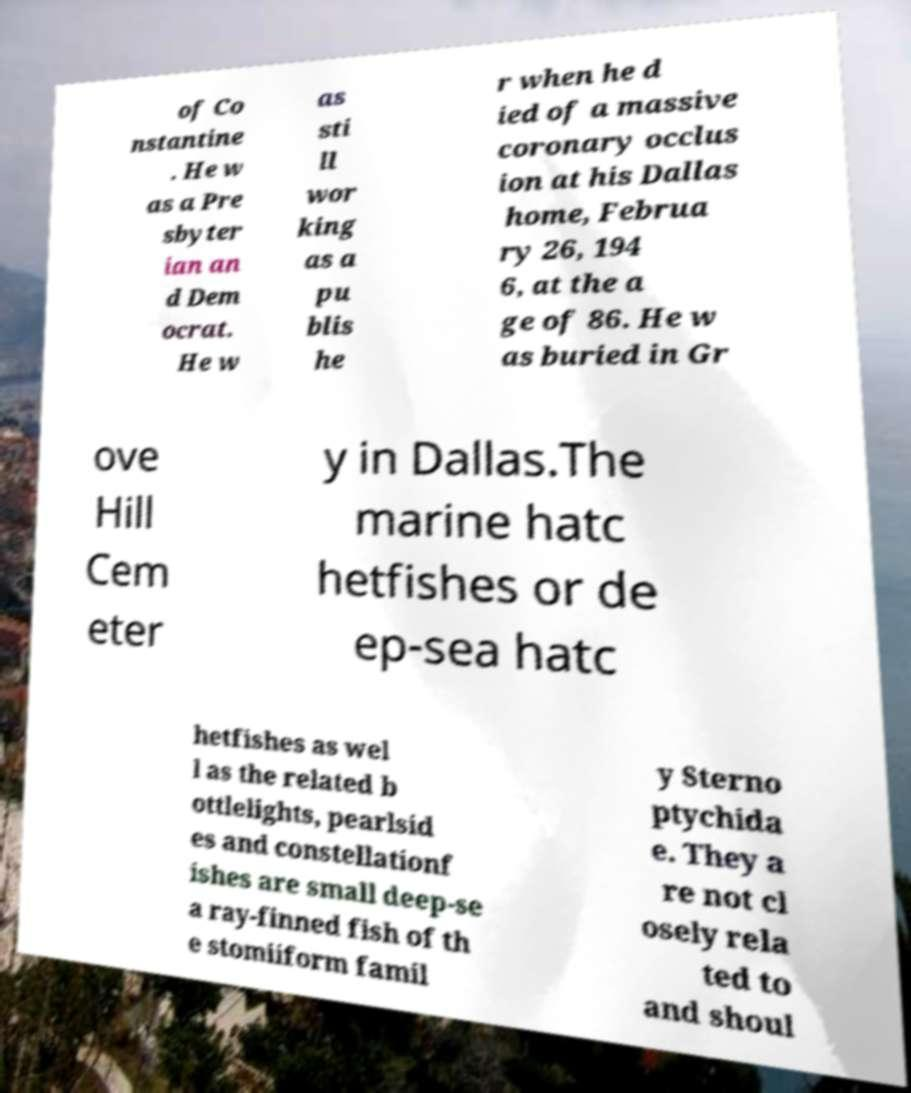Can you accurately transcribe the text from the provided image for me? of Co nstantine . He w as a Pre sbyter ian an d Dem ocrat. He w as sti ll wor king as a pu blis he r when he d ied of a massive coronary occlus ion at his Dallas home, Februa ry 26, 194 6, at the a ge of 86. He w as buried in Gr ove Hill Cem eter y in Dallas.The marine hatc hetfishes or de ep-sea hatc hetfishes as wel l as the related b ottlelights, pearlsid es and constellationf ishes are small deep-se a ray-finned fish of th e stomiiform famil y Sterno ptychida e. They a re not cl osely rela ted to and shoul 